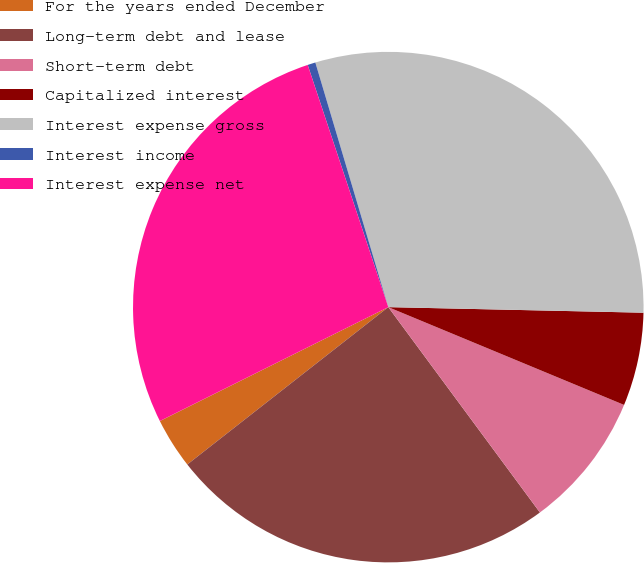Convert chart. <chart><loc_0><loc_0><loc_500><loc_500><pie_chart><fcel>For the years ended December<fcel>Long-term debt and lease<fcel>Short-term debt<fcel>Capitalized interest<fcel>Interest expense gross<fcel>Interest income<fcel>Interest expense net<nl><fcel>3.21%<fcel>24.55%<fcel>8.62%<fcel>5.91%<fcel>29.96%<fcel>0.5%<fcel>27.25%<nl></chart> 